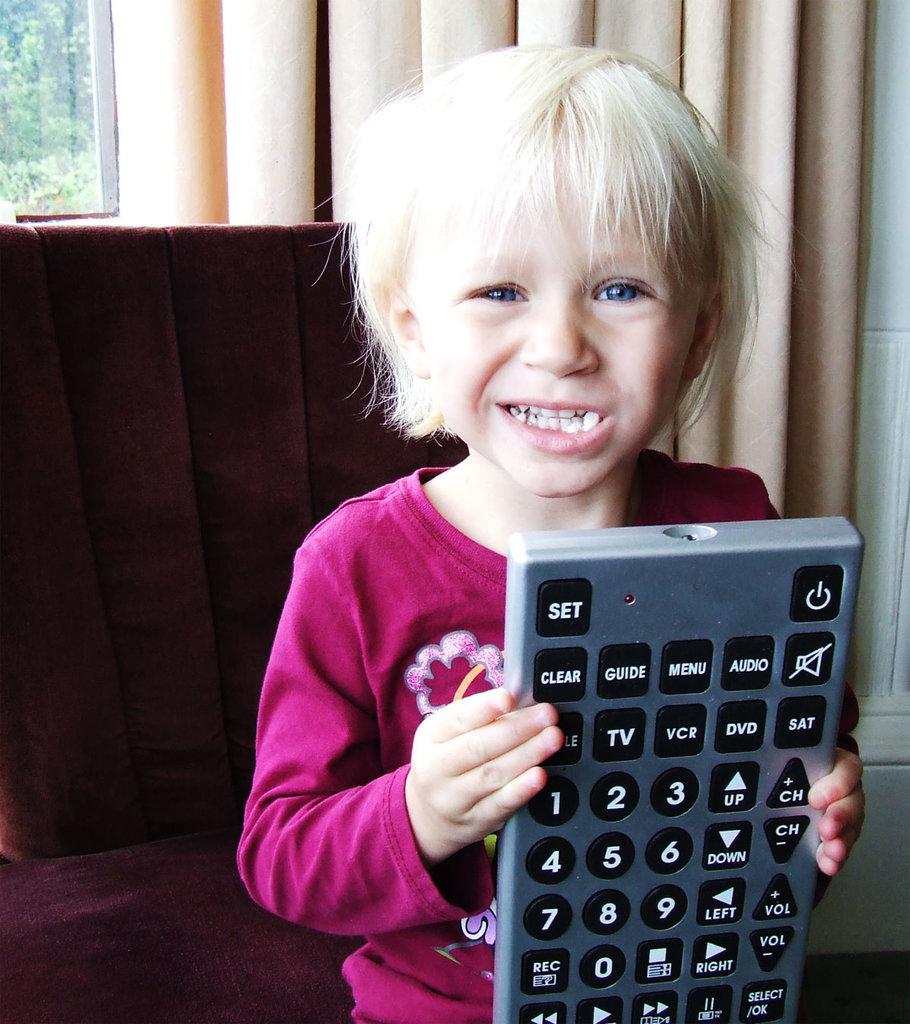What word is written on the upper left button?
Offer a terse response. Set. 